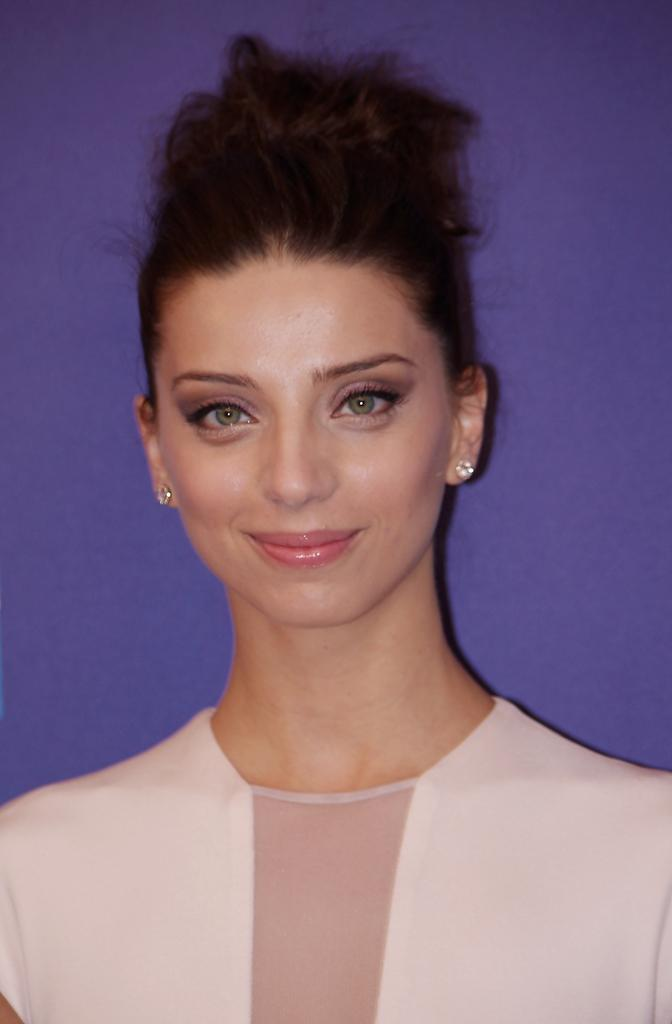Who is the main subject in the image? There is a lady in the image. Where is the lady positioned in the image? The lady is in the center of the image. What type of trouble is the lady causing in the image? There is no indication of any trouble being caused by the lady in the image. What is the name of the lady in the image? The name of the lady is not mentioned or visible in the image. 